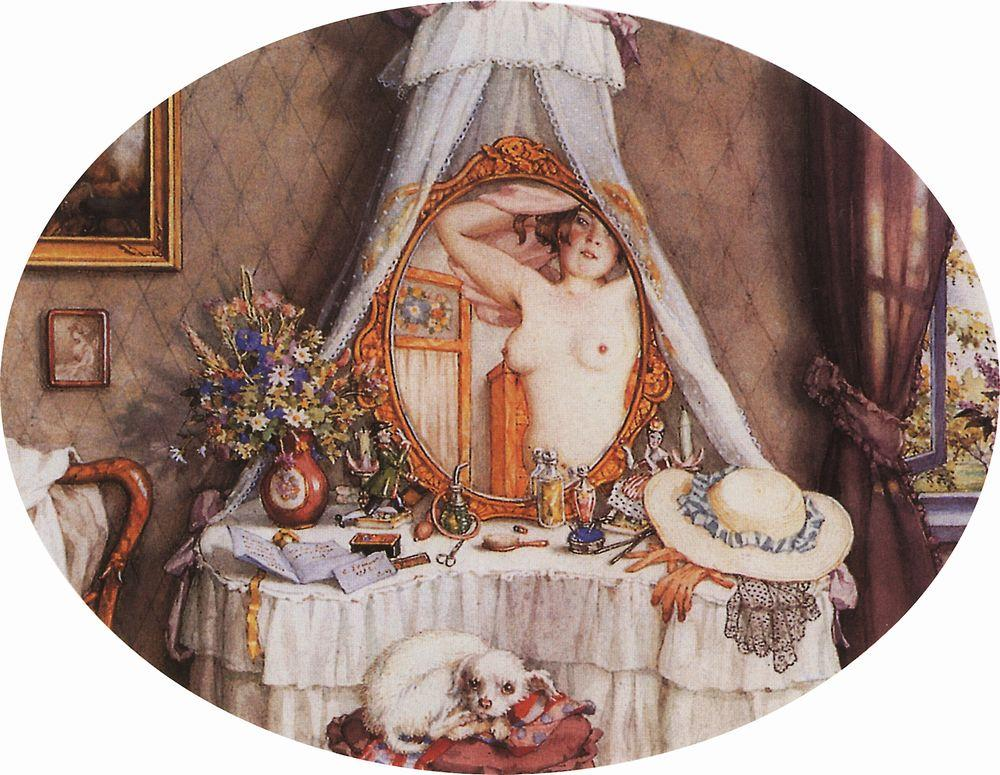What narrative do you think could be behind this scene? This scene could depict a woman preparing for an important day ahead. Perhaps she is getting ready to attend a significant event, such as a social gathering or a reunion. The careful setting and her moment of reflection in the mirror might indicate that she is contemplating her appearance and attire. The presence of the dog implies she values companionship, and the intricate décor suggests she has a refined taste or a sentimental attachment to these objects. The painting captures a snapshot of her life, highlighting an intimate moment that is both personal and relatable. 